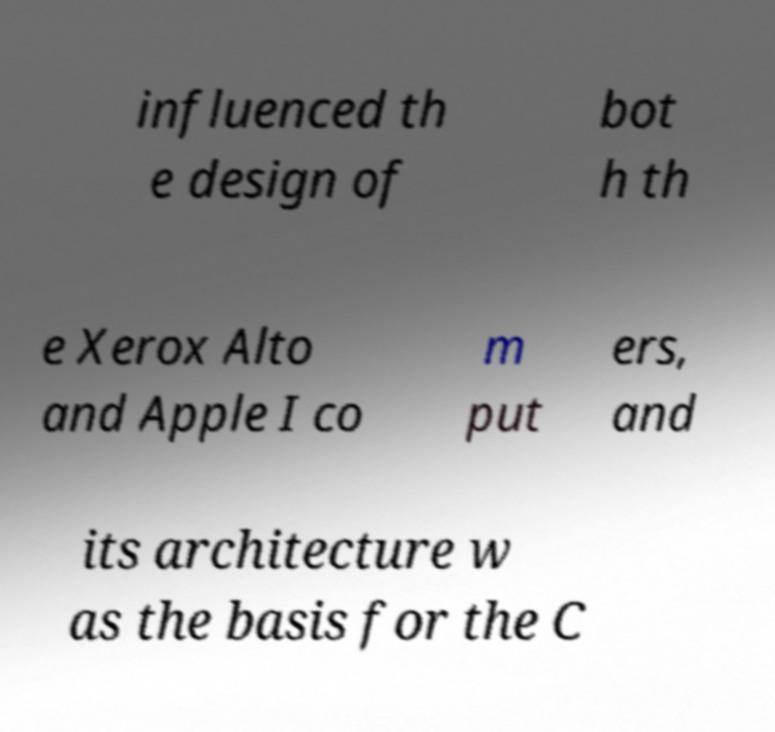I need the written content from this picture converted into text. Can you do that? influenced th e design of bot h th e Xerox Alto and Apple I co m put ers, and its architecture w as the basis for the C 